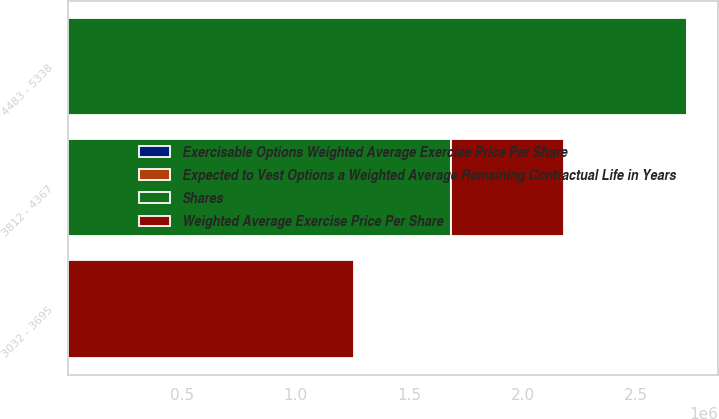Convert chart. <chart><loc_0><loc_0><loc_500><loc_500><stacked_bar_chart><ecel><fcel>3032 - 3695<fcel>3812 - 4367<fcel>4483 - 5338<nl><fcel>Shares<fcel>53.36<fcel>1.68535e+06<fcel>2.72452e+06<nl><fcel>Expected to Vest Options a Weighted Average Remaining Contractual Life in Years<fcel>35.14<fcel>43.56<fcel>53.36<nl><fcel>Exercisable Options Weighted Average Exercise Price Per Share<fcel>2.4<fcel>2.1<fcel>4<nl><fcel>Weighted Average Exercise Price Per Share<fcel>1.25945e+06<fcel>496175<fcel>500<nl></chart> 